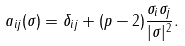<formula> <loc_0><loc_0><loc_500><loc_500>a _ { i j } ( \sigma ) = \delta _ { i j } + ( p - 2 ) \frac { \sigma _ { i } \sigma _ { j } } { | \sigma | ^ { 2 } } .</formula> 